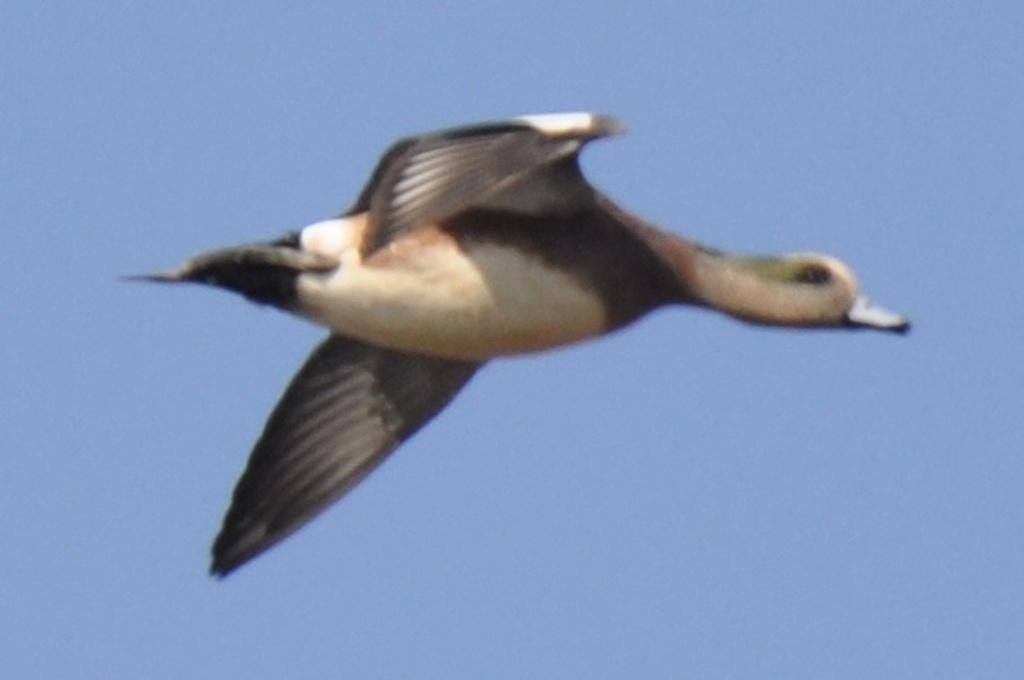What is the main subject of the image? The main subject of the image is a bird flying in the air. What is visible in the background of the image? The sky is visible in the image. Can you see any ghosts in the image? There are no ghosts present in the image. What type of drug can be seen in the image? There is no drug present in the image; it features a bird flying in the air with the sky visible in the background. 